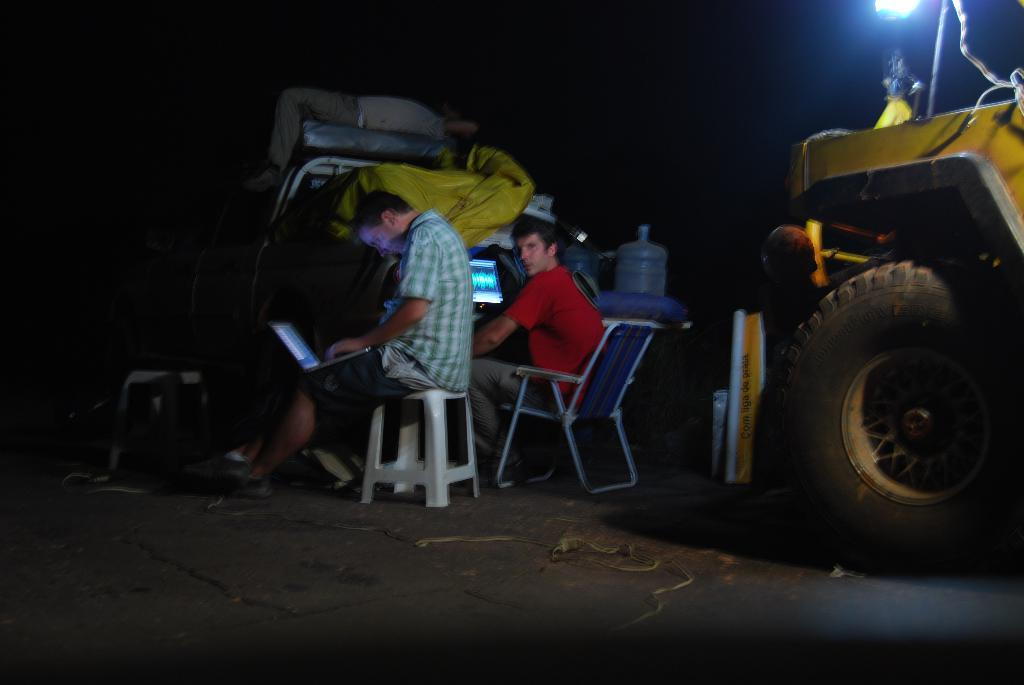How many people are in the image? There are two persons in the image. What objects are present in the image that might be used for sitting? There are chairs in the image. What electronic devices can be seen in the image? There are laptops in the image. What object is used for watering plants in the image? There is a water can in the image. What type of vehicle is visible in the image? There is a vehicle in the image. What can be said about the lighting in the image? The background of the image is dark. What type of grape is being used to rake the land in the image? There is no grape or rake present in the image, and no land is being raked. 